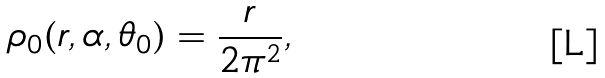Convert formula to latex. <formula><loc_0><loc_0><loc_500><loc_500>\rho _ { 0 } ( r , \alpha , \theta _ { 0 } ) = \frac { r } { 2 \pi ^ { 2 } } ,</formula> 